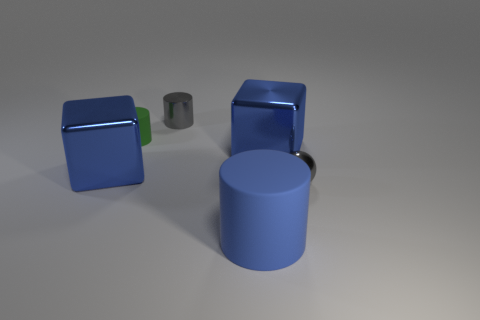Do the rubber object to the right of the tiny matte cylinder and the blue object that is to the left of the green matte object have the same size?
Provide a succinct answer. Yes. How many blocks are large objects or small green matte things?
Provide a short and direct response. 2. What number of metallic things are blue cylinders or brown things?
Give a very brief answer. 0. There is a blue thing that is the same shape as the tiny green object; what size is it?
Provide a succinct answer. Large. Is there anything else that has the same size as the gray metal ball?
Make the answer very short. Yes. Does the blue matte thing have the same size as the gray object in front of the green rubber cylinder?
Ensure brevity in your answer.  No. The gray metal object that is behind the small green rubber thing has what shape?
Offer a terse response. Cylinder. The big metallic thing that is behind the big cube that is left of the green cylinder is what color?
Your answer should be compact. Blue. What is the color of the other rubber object that is the same shape as the green rubber object?
Give a very brief answer. Blue. What number of large rubber things have the same color as the sphere?
Offer a terse response. 0. 